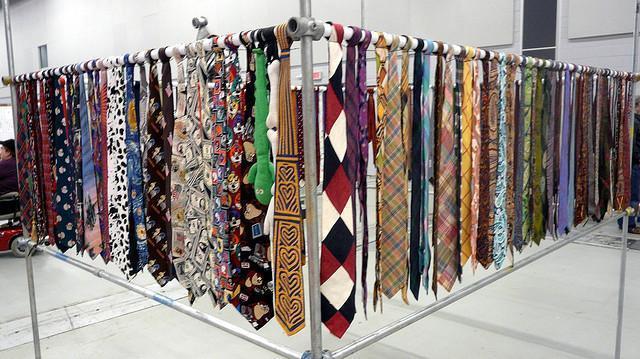How many ties are there?
Give a very brief answer. 10. 